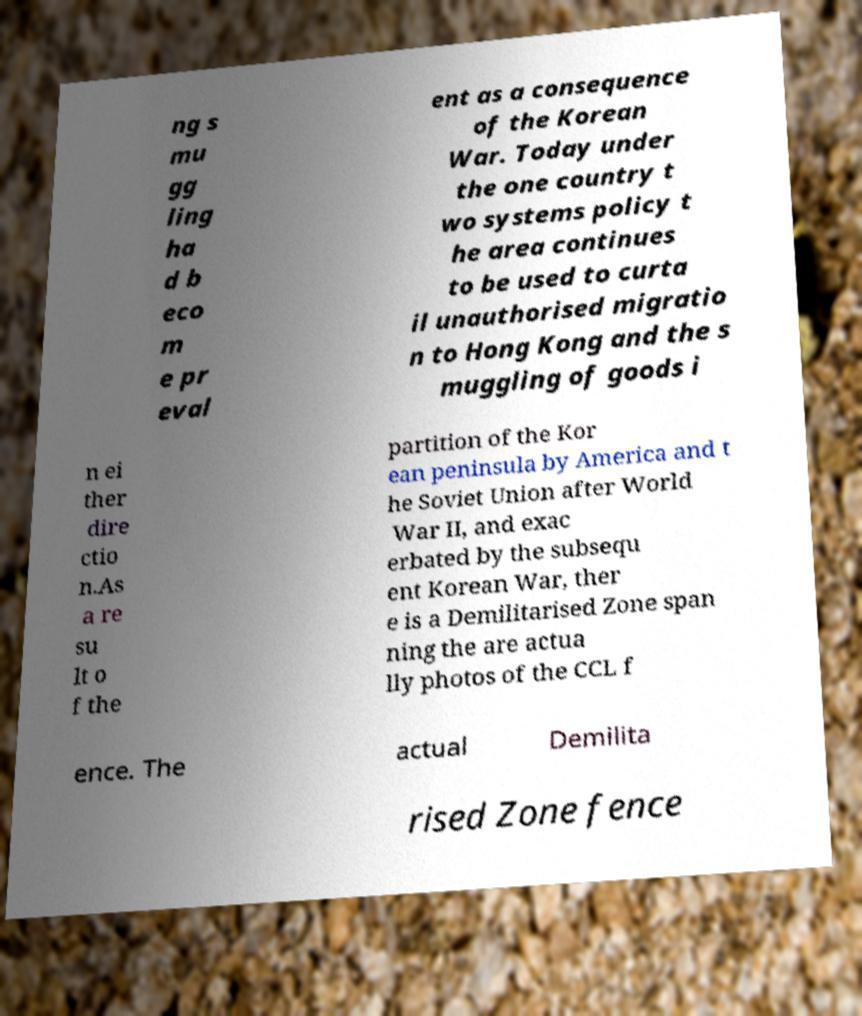Can you read and provide the text displayed in the image?This photo seems to have some interesting text. Can you extract and type it out for me? ng s mu gg ling ha d b eco m e pr eval ent as a consequence of the Korean War. Today under the one country t wo systems policy t he area continues to be used to curta il unauthorised migratio n to Hong Kong and the s muggling of goods i n ei ther dire ctio n.As a re su lt o f the partition of the Kor ean peninsula by America and t he Soviet Union after World War II, and exac erbated by the subsequ ent Korean War, ther e is a Demilitarised Zone span ning the are actua lly photos of the CCL f ence. The actual Demilita rised Zone fence 